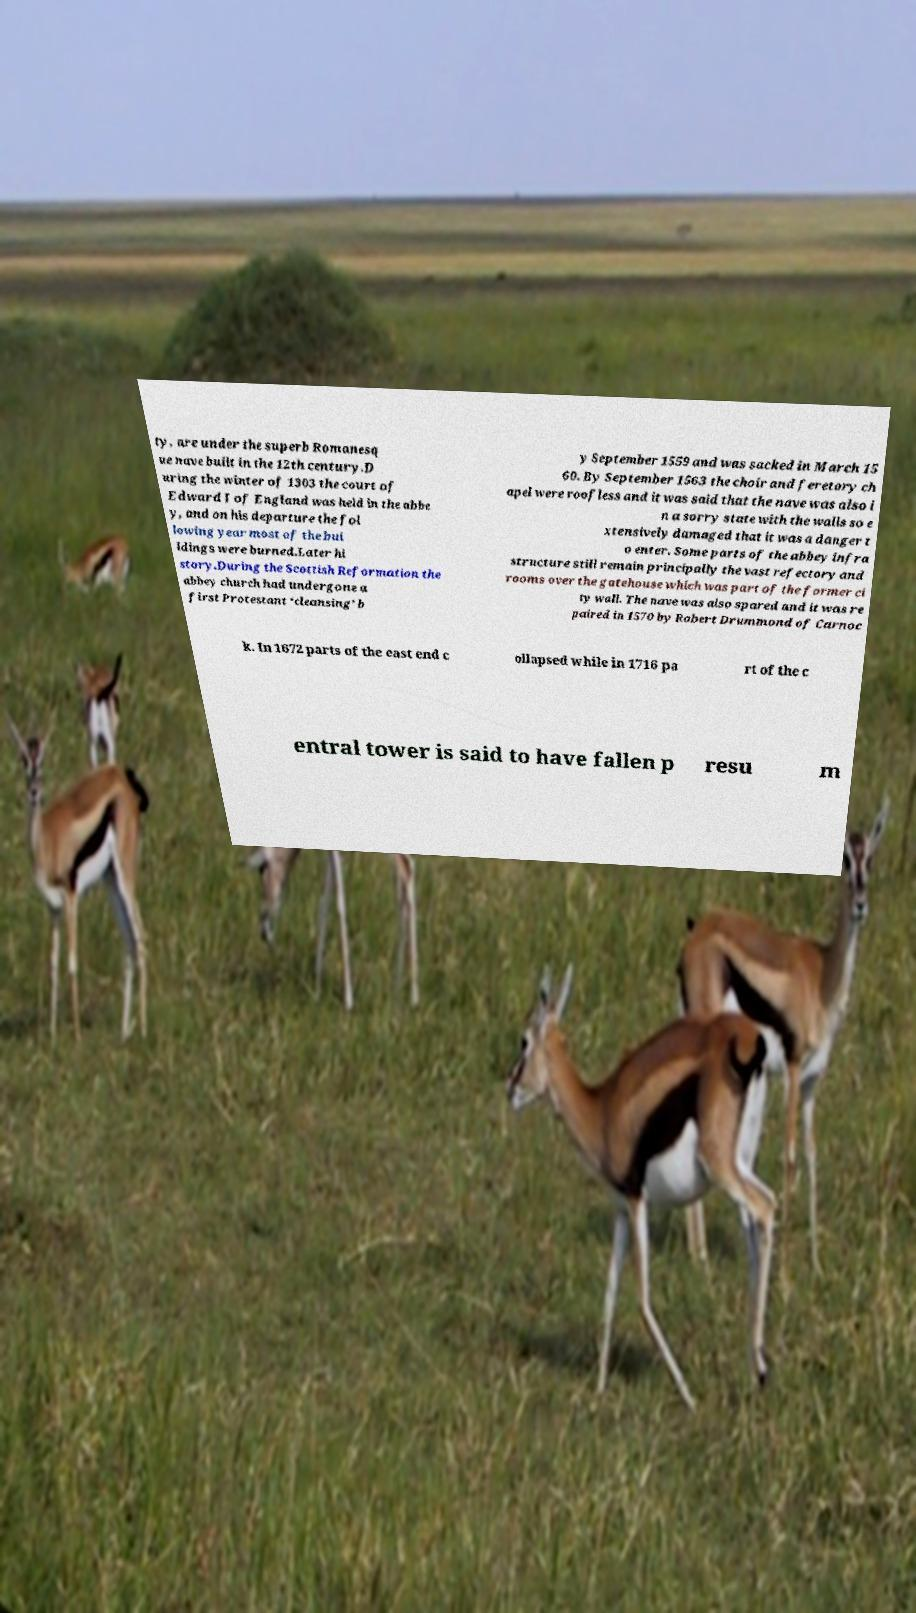Can you accurately transcribe the text from the provided image for me? ty, are under the superb Romanesq ue nave built in the 12th century.D uring the winter of 1303 the court of Edward I of England was held in the abbe y, and on his departure the fol lowing year most of the bui ldings were burned.Later hi story.During the Scottish Reformation the abbey church had undergone a first Protestant ‘cleansing’ b y September 1559 and was sacked in March 15 60. By September 1563 the choir and feretory ch apel were roofless and it was said that the nave was also i n a sorry state with the walls so e xtensively damaged that it was a danger t o enter. Some parts of the abbey infra structure still remain principally the vast refectory and rooms over the gatehouse which was part of the former ci ty wall. The nave was also spared and it was re paired in 1570 by Robert Drummond of Carnoc k. In 1672 parts of the east end c ollapsed while in 1716 pa rt of the c entral tower is said to have fallen p resu m 